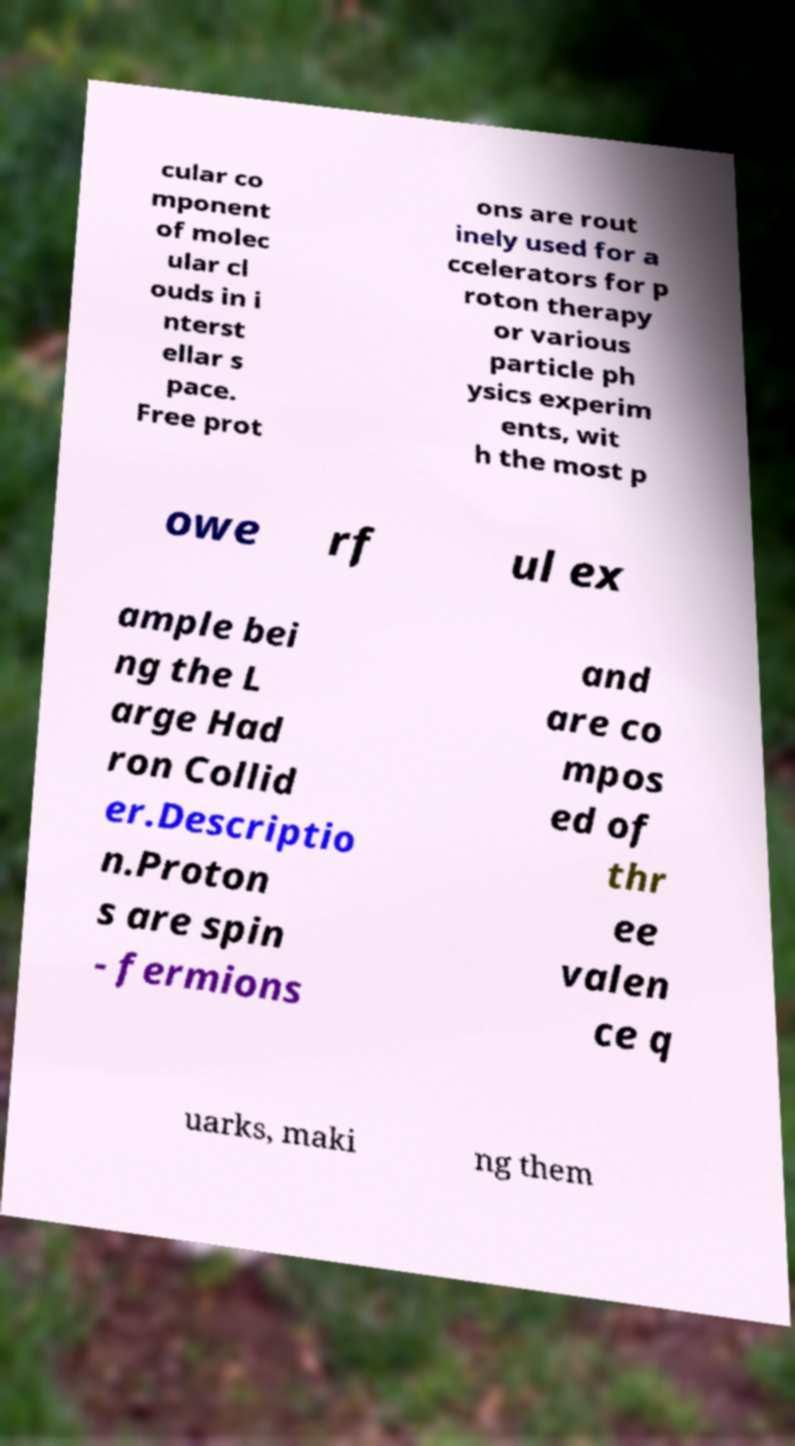Please read and relay the text visible in this image. What does it say? cular co mponent of molec ular cl ouds in i nterst ellar s pace. Free prot ons are rout inely used for a ccelerators for p roton therapy or various particle ph ysics experim ents, wit h the most p owe rf ul ex ample bei ng the L arge Had ron Collid er.Descriptio n.Proton s are spin - fermions and are co mpos ed of thr ee valen ce q uarks, maki ng them 